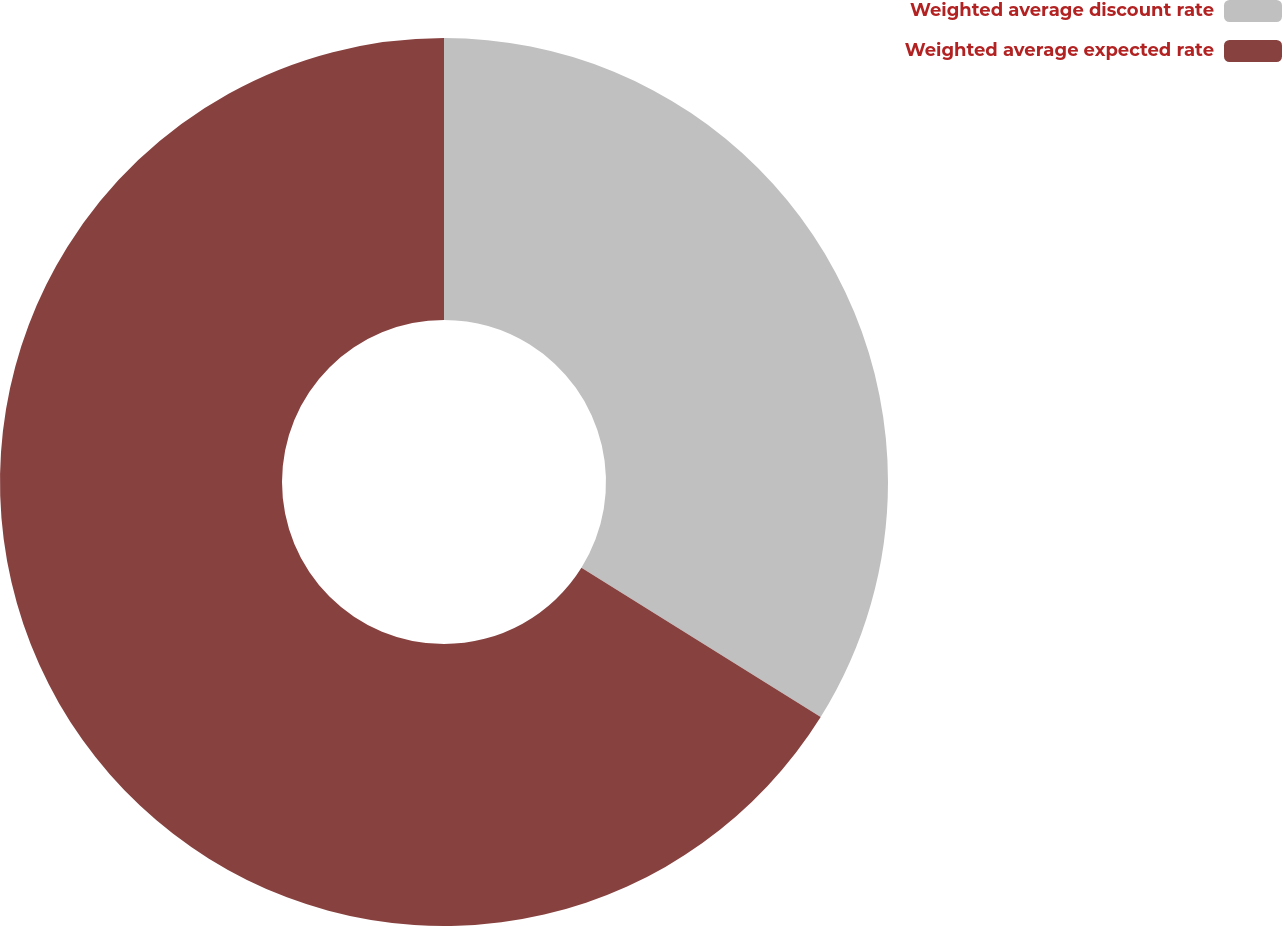<chart> <loc_0><loc_0><loc_500><loc_500><pie_chart><fcel>Weighted average discount rate<fcel>Weighted average expected rate<nl><fcel>33.88%<fcel>66.12%<nl></chart> 